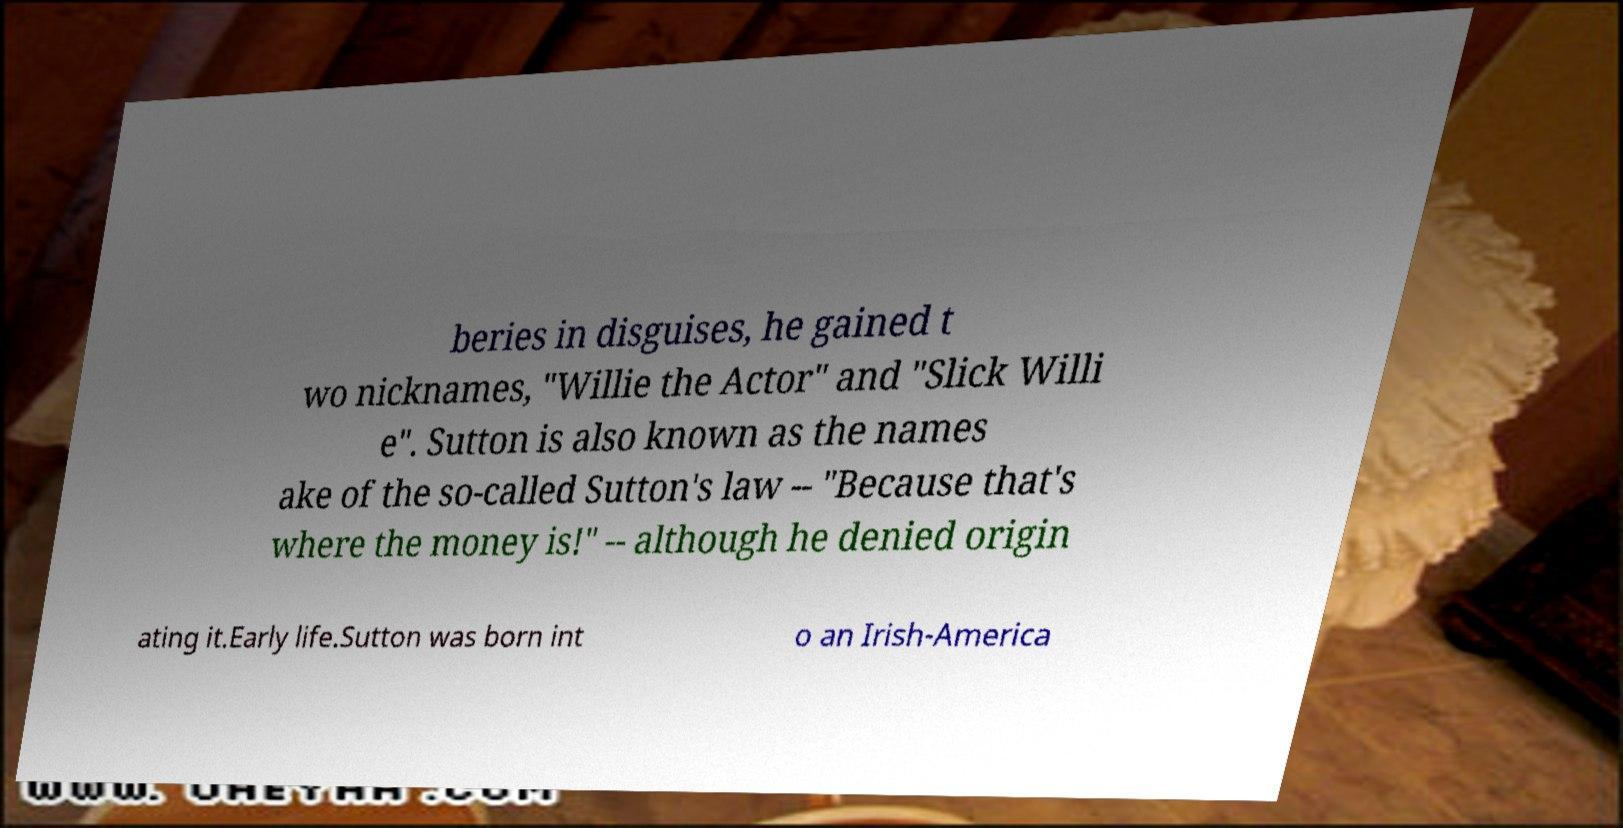I need the written content from this picture converted into text. Can you do that? beries in disguises, he gained t wo nicknames, "Willie the Actor" and "Slick Willi e". Sutton is also known as the names ake of the so-called Sutton's law -- "Because that's where the money is!" -- although he denied origin ating it.Early life.Sutton was born int o an Irish-America 